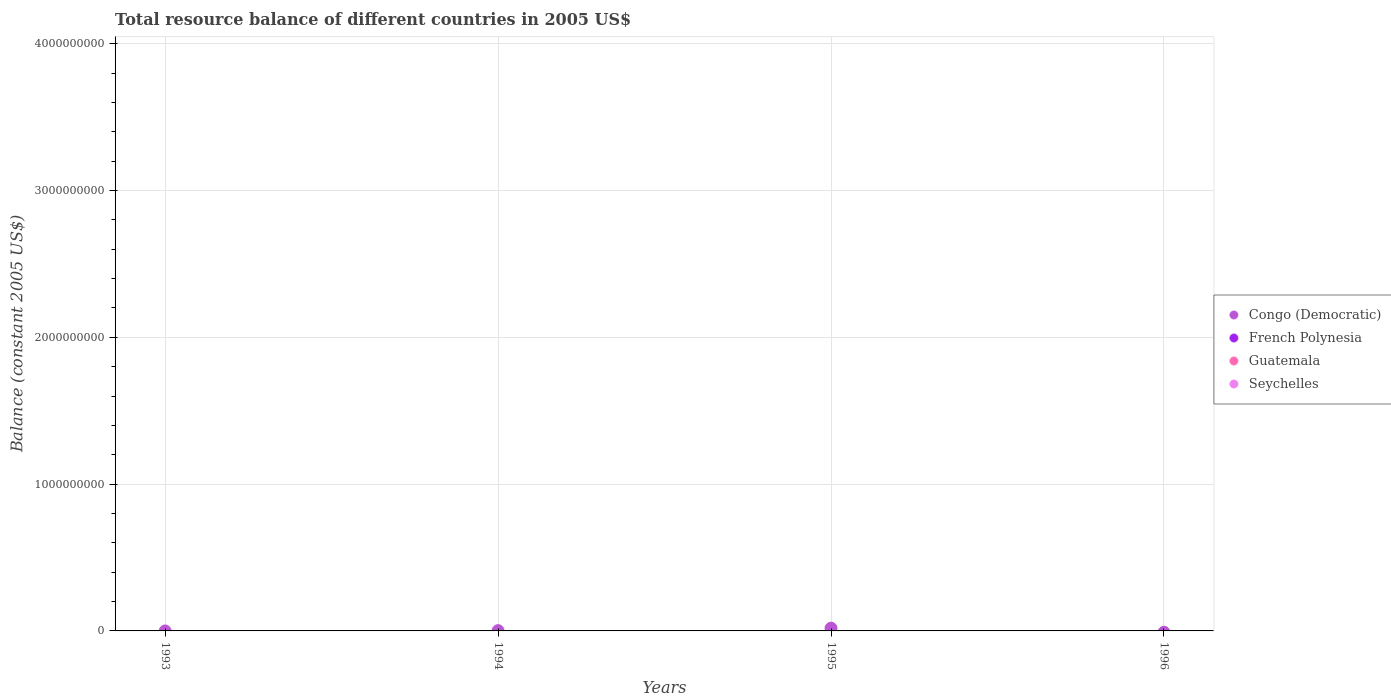How many different coloured dotlines are there?
Offer a terse response. 1. Is the number of dotlines equal to the number of legend labels?
Offer a very short reply. No. In which year was the total resource balance in Congo (Democratic) maximum?
Offer a very short reply. 1995. What is the total total resource balance in Congo (Democratic) in the graph?
Ensure brevity in your answer.  2.08e+07. What is the difference between the total resource balance in Congo (Democratic) in 1994 and that in 1995?
Offer a very short reply. -1.70e+07. What is the average total resource balance in Seychelles per year?
Ensure brevity in your answer.  0. In how many years, is the total resource balance in French Polynesia greater than 1000000000 US$?
Make the answer very short. 0. Is the total resource balance in Congo (Democratic) in 1994 less than that in 1995?
Your answer should be compact. Yes. What is the difference between the highest and the lowest total resource balance in Congo (Democratic)?
Provide a short and direct response. 1.89e+07. Is the total resource balance in Guatemala strictly greater than the total resource balance in Congo (Democratic) over the years?
Provide a succinct answer. No. Is the total resource balance in Guatemala strictly less than the total resource balance in French Polynesia over the years?
Offer a terse response. No. How many dotlines are there?
Offer a terse response. 1. Does the graph contain any zero values?
Provide a short and direct response. Yes. Does the graph contain grids?
Your answer should be compact. Yes. Where does the legend appear in the graph?
Ensure brevity in your answer.  Center right. How many legend labels are there?
Provide a short and direct response. 4. How are the legend labels stacked?
Your response must be concise. Vertical. What is the title of the graph?
Provide a short and direct response. Total resource balance of different countries in 2005 US$. What is the label or title of the Y-axis?
Offer a very short reply. Balance (constant 2005 US$). What is the Balance (constant 2005 US$) in Congo (Democratic) in 1993?
Your answer should be very brief. 6000. What is the Balance (constant 2005 US$) in French Polynesia in 1993?
Keep it short and to the point. 0. What is the Balance (constant 2005 US$) in Guatemala in 1993?
Make the answer very short. 0. What is the Balance (constant 2005 US$) of Congo (Democratic) in 1994?
Your answer should be very brief. 1.90e+06. What is the Balance (constant 2005 US$) of Congo (Democratic) in 1995?
Your response must be concise. 1.89e+07. What is the Balance (constant 2005 US$) in French Polynesia in 1995?
Ensure brevity in your answer.  0. What is the Balance (constant 2005 US$) in Guatemala in 1995?
Your answer should be compact. 0. What is the Balance (constant 2005 US$) in Seychelles in 1995?
Offer a terse response. 0. What is the Balance (constant 2005 US$) of Congo (Democratic) in 1996?
Ensure brevity in your answer.  0. What is the Balance (constant 2005 US$) of Seychelles in 1996?
Offer a terse response. 0. Across all years, what is the maximum Balance (constant 2005 US$) in Congo (Democratic)?
Make the answer very short. 1.89e+07. Across all years, what is the minimum Balance (constant 2005 US$) of Congo (Democratic)?
Keep it short and to the point. 0. What is the total Balance (constant 2005 US$) in Congo (Democratic) in the graph?
Provide a succinct answer. 2.08e+07. What is the total Balance (constant 2005 US$) of Seychelles in the graph?
Your answer should be compact. 0. What is the difference between the Balance (constant 2005 US$) in Congo (Democratic) in 1993 and that in 1994?
Offer a terse response. -1.89e+06. What is the difference between the Balance (constant 2005 US$) of Congo (Democratic) in 1993 and that in 1995?
Keep it short and to the point. -1.88e+07. What is the difference between the Balance (constant 2005 US$) in Congo (Democratic) in 1994 and that in 1995?
Offer a terse response. -1.70e+07. What is the average Balance (constant 2005 US$) of Congo (Democratic) per year?
Your answer should be compact. 5.19e+06. What is the ratio of the Balance (constant 2005 US$) in Congo (Democratic) in 1993 to that in 1994?
Offer a terse response. 0. What is the ratio of the Balance (constant 2005 US$) in Congo (Democratic) in 1994 to that in 1995?
Your response must be concise. 0.1. What is the difference between the highest and the second highest Balance (constant 2005 US$) in Congo (Democratic)?
Offer a very short reply. 1.70e+07. What is the difference between the highest and the lowest Balance (constant 2005 US$) of Congo (Democratic)?
Your response must be concise. 1.89e+07. 